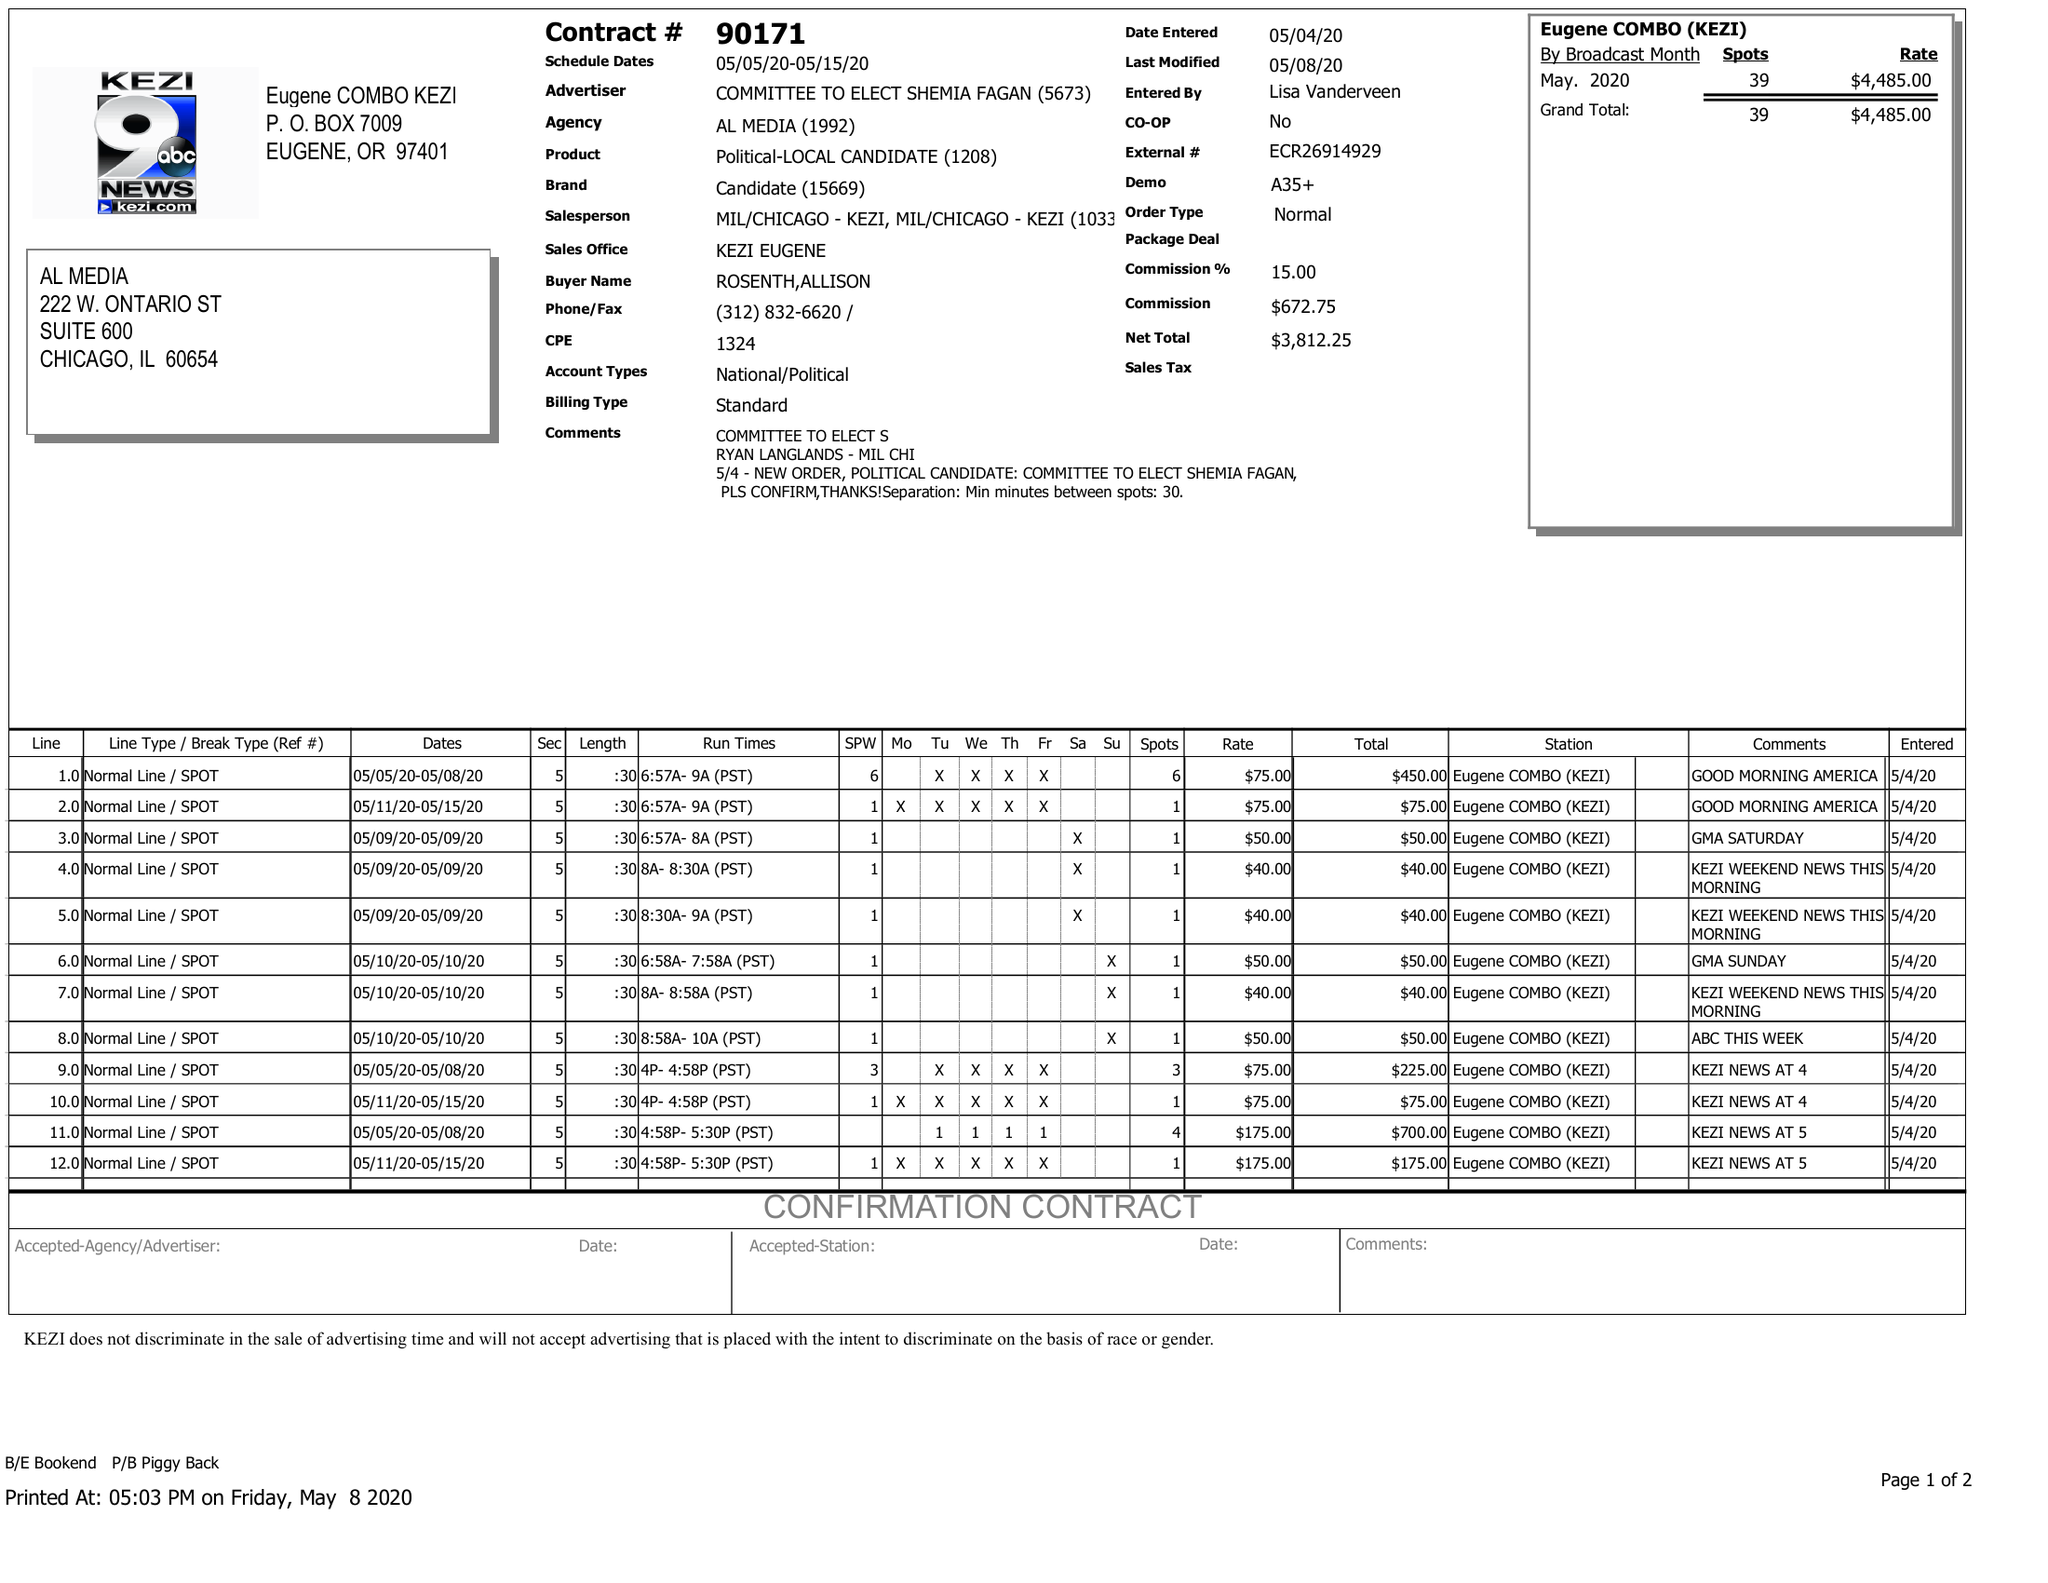What is the value for the gross_amount?
Answer the question using a single word or phrase. 4485.00 